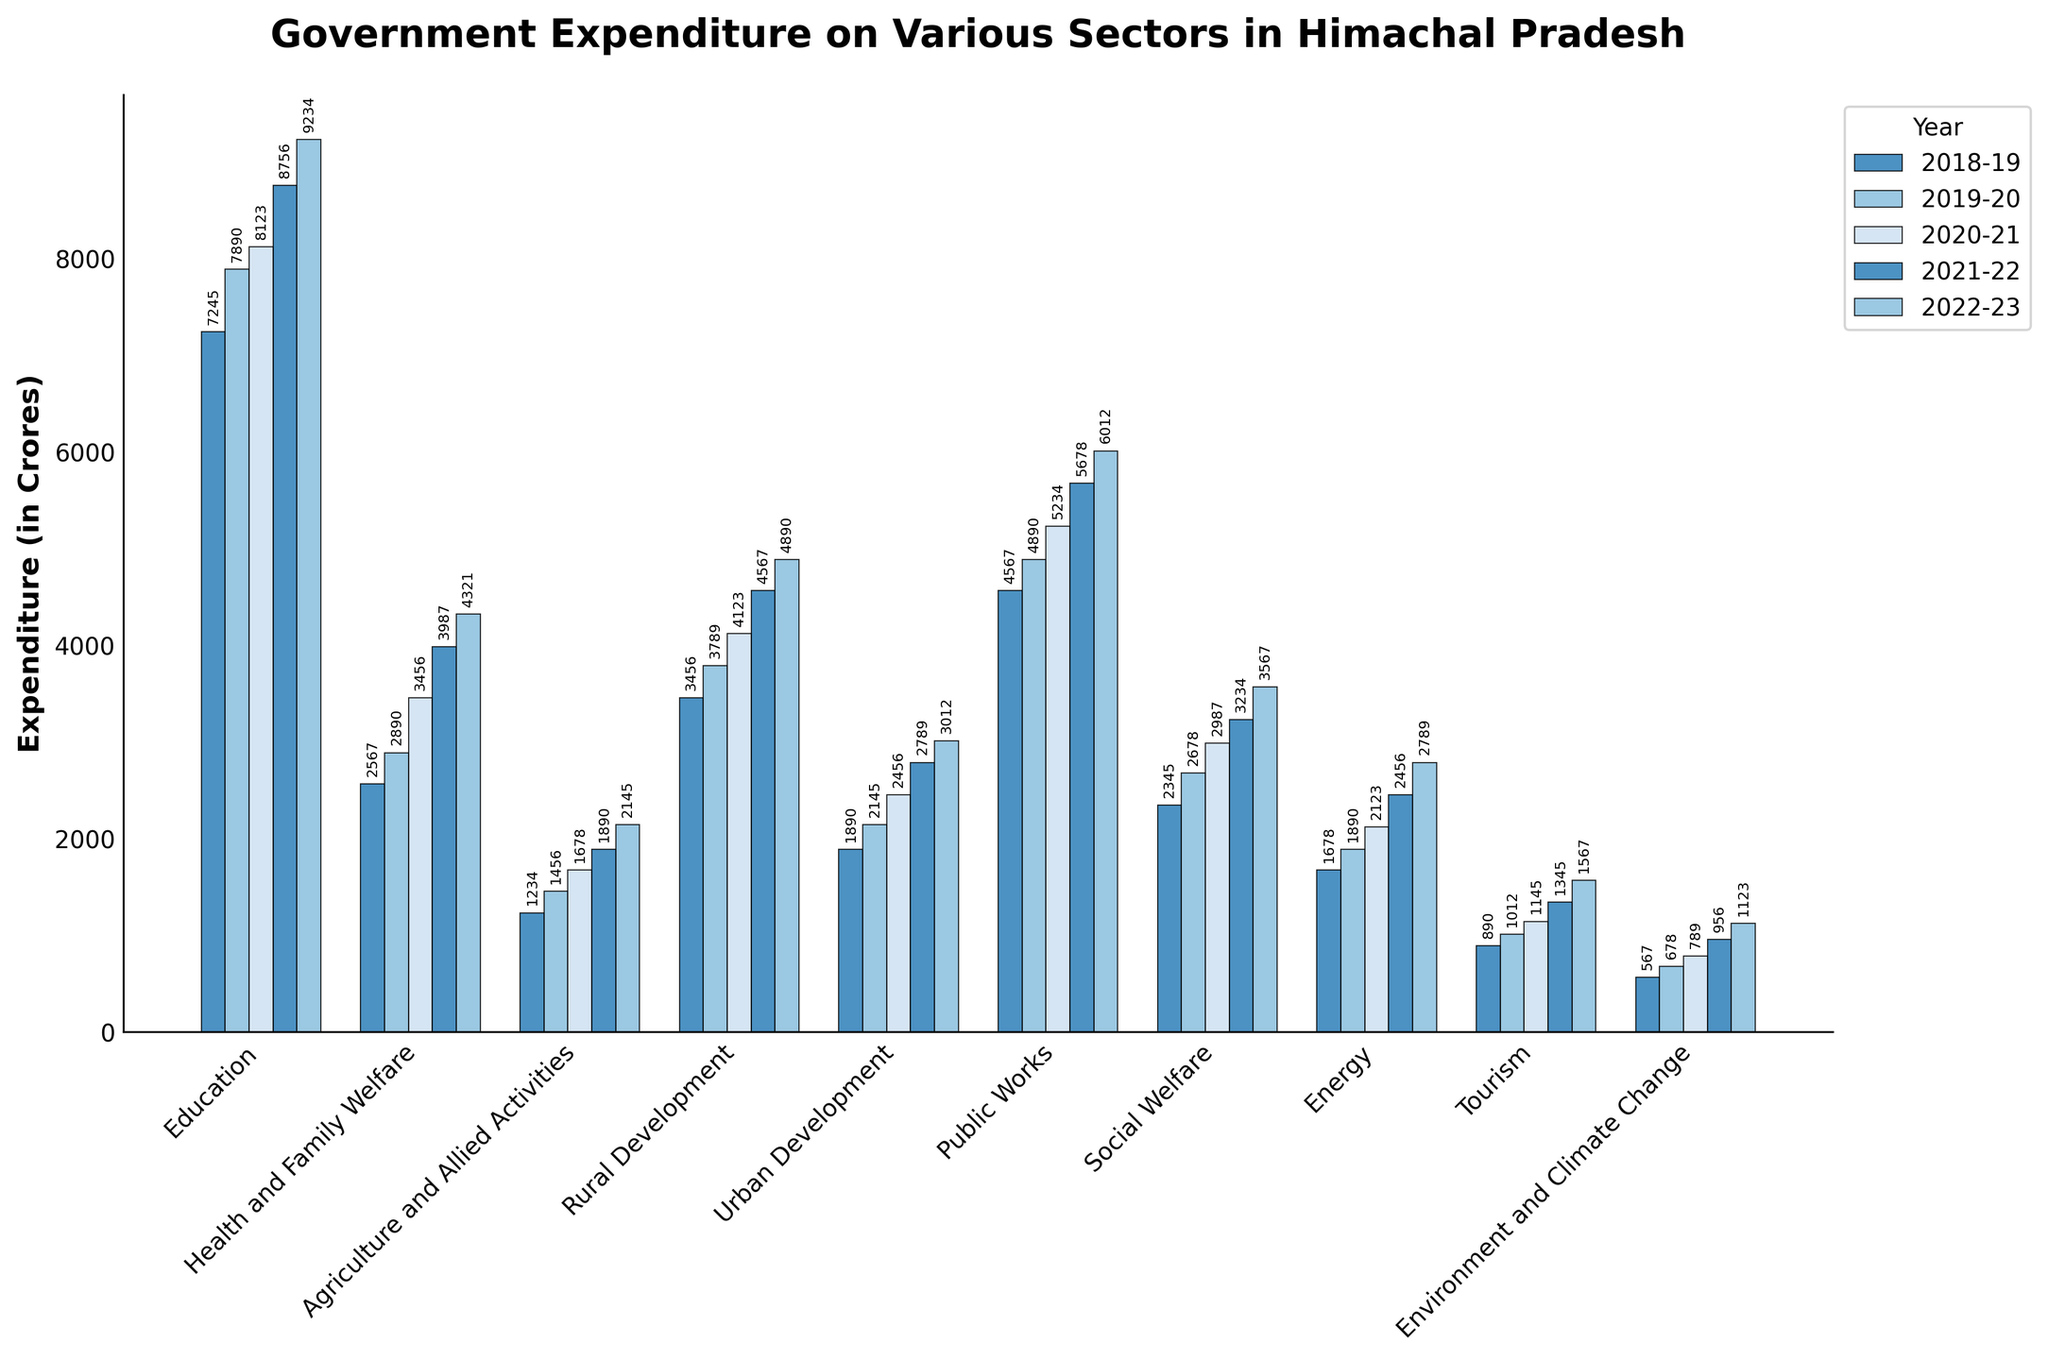What is the total expenditure on Education from 2018-19 to 2022-23? To find the total expenditure on Education, sum the values for all the years: 7245 + 7890 + 8123 + 8756 + 9234.
Answer: 41248 Which sector saw the highest increase in expenditure over the 5-year period? To find this, calculate the increase for each sector by subtracting the expenditure in 2018-19 from 2022-23, and then determine the highest increase. For example, for Education:
9234 - 7245 = 1989. After doing this for all sectors, it is clear that Education has the highest increase.
Answer: Education By how much did the expenditure on Health and Family Welfare increase from 2018-19 to 2022-23? Subtract the expenditure in 2018-19 from that in 2022-23: 4321 - 2567.
Answer: 1754 Which sector had the lowest expenditure in 2022-23 and what was the value? Examine the bar for 2022-23 for each sector and identify the shortest one. The value is shown above the bar. The sector is Environment and Climate Change.
Answer: Environment and Climate Change, 1123 Compare the expenditure on Urban Development and Tourism in 2020-21. Which one had a higher expenditure and by how much? Find the values for 2020-21 for both sectors: Urban Development is 2456 and Tourism is 1145. Subtract the smaller value from the larger one: 2456 - 1145.
Answer: Urban Development, 1311 What was the difference in expenditure between Agriculture and Allied Activities and Social Welfare in 2021-22? Subtract the value for Agriculture and Allied Activities from that for Social Welfare in 2021-22: 3234 - 1890.
Answer: 1344 What is the average annual expenditure on Energy over the 5 years? Sum the values for the 5 years and divide by the number of years: (1678 + 1890 + 2123 + 2456 + 2789) / 5.
Answer: 2187.2 How did the expenditure on Public Works change from 2018-19 to 2022-23? Subtract the 2018-19 value from the 2022-23 value: 6012 - 4567.
Answer: Increased by 1445 Which year had the highest total government expenditure across all sectors, and what was the total expenditure? Sum the expenditures for each year and compare the totals to find the highest. For example, for 2022-23, sum the expenditures of all sectors: 
9234 + 4321 + 2145 + 4890 + 3012 + 6012 + 3567 + 2789 + 1567 + 1123 = 38660. Perform this for each year and identify the highest total.
Answer: 2022-23, 38660 What is the percentage increase in expenditure for Rural Development from 2018-19 to 2022-23? Find the difference first: 4890 - 3456. Then, divide the difference by the 2018-19 value and multiply by 100 to get the percentage: (4890 - 3456) / 3456 * 100.
Answer: 41.51% 